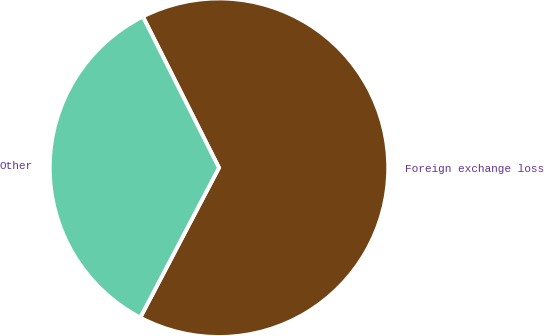Convert chart. <chart><loc_0><loc_0><loc_500><loc_500><pie_chart><fcel>Foreign exchange loss<fcel>Other<nl><fcel>65.12%<fcel>34.88%<nl></chart> 